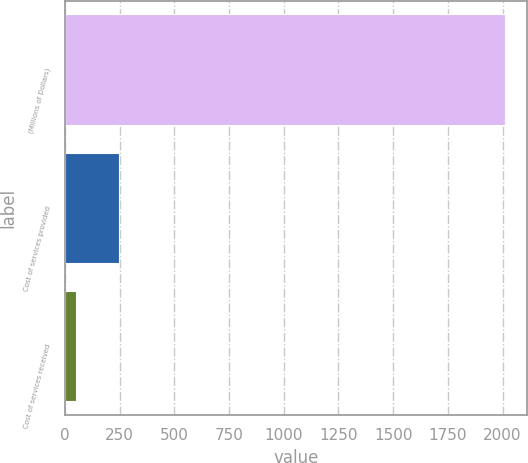<chart> <loc_0><loc_0><loc_500><loc_500><bar_chart><fcel>(Millions of Dollars)<fcel>Cost of services provided<fcel>Cost of services received<nl><fcel>2013<fcel>248.1<fcel>52<nl></chart> 